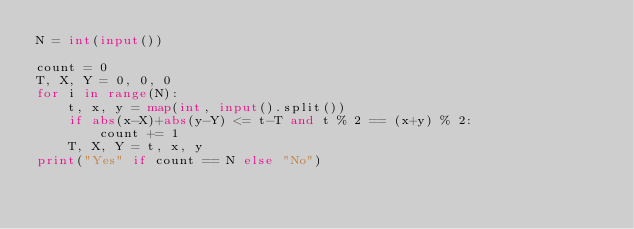<code> <loc_0><loc_0><loc_500><loc_500><_Python_>N = int(input())

count = 0
T, X, Y = 0, 0, 0
for i in range(N):
    t, x, y = map(int, input().split())
    if abs(x-X)+abs(y-Y) <= t-T and t % 2 == (x+y) % 2:
        count += 1
    T, X, Y = t, x, y
print("Yes" if count == N else "No")
</code> 